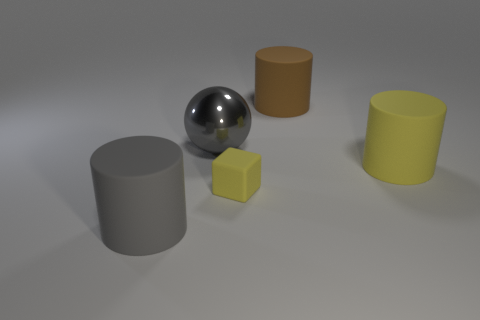Is there anything else that is the same material as the large ball?
Your response must be concise. No. The cylinder to the left of the yellow thing in front of the large object that is right of the large brown matte cylinder is made of what material?
Provide a short and direct response. Rubber. Is the number of brown matte cylinders to the right of the large gray cylinder greater than the number of gray cylinders behind the big brown rubber object?
Your answer should be very brief. Yes. What number of large cylinders have the same material as the tiny yellow block?
Keep it short and to the point. 3. Does the yellow object that is behind the tiny block have the same shape as the big brown thing that is behind the big yellow cylinder?
Provide a succinct answer. Yes. There is a big cylinder on the right side of the brown matte cylinder; what color is it?
Your answer should be very brief. Yellow. Are there any gray objects of the same shape as the big brown object?
Give a very brief answer. Yes. What is the material of the sphere?
Make the answer very short. Metal. What is the size of the cylinder that is both right of the gray matte cylinder and in front of the large brown cylinder?
Give a very brief answer. Large. What is the material of the big thing that is the same color as the rubber cube?
Your answer should be compact. Rubber. 